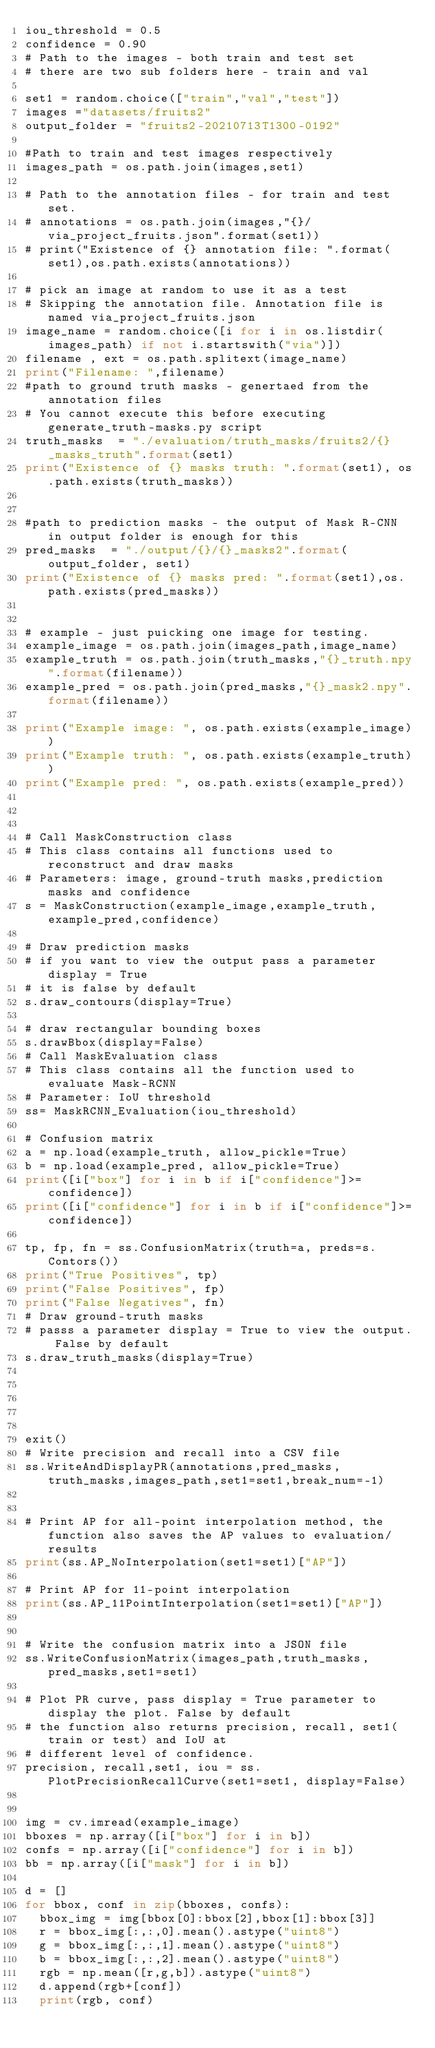<code> <loc_0><loc_0><loc_500><loc_500><_Python_>iou_threshold = 0.5
confidence = 0.90
# Path to the images - both train and test set
# there are two sub folders here - train and val

set1 = random.choice(["train","val","test"])
images ="datasets/fruits2"
output_folder = "fruits2-20210713T1300-0192"

#Path to train and test images respectively
images_path = os.path.join(images,set1)

# Path to the annotation files - for train and test set.
# annotations = os.path.join(images,"{}/via_project_fruits.json".format(set1))
# print("Existence of {} annotation file: ".format(set1),os.path.exists(annotations))

# pick an image at random to use it as a test 
# Skipping the annotation file. Annotation file is named via_project_fruits.json
image_name = random.choice([i for i in os.listdir(images_path) if not i.startswith("via")])
filename , ext = os.path.splitext(image_name)
print("Filename: ",filename)
#path to ground truth masks - genertaed from the annotation files
# You cannot execute this before executing generate_truth-masks.py script
truth_masks  = "./evaluation/truth_masks/fruits2/{}_masks_truth".format(set1)
print("Existence of {} masks truth: ".format(set1), os.path.exists(truth_masks))


#path to prediction masks - the output of Mask R-CNN in output folder is enough for this
pred_masks  = "./output/{}/{}_masks2".format(output_folder, set1)
print("Existence of {} masks pred: ".format(set1),os.path.exists(pred_masks))


# example - just puicking one image for testing.
example_image = os.path.join(images_path,image_name)
example_truth = os.path.join(truth_masks,"{}_truth.npy".format(filename))
example_pred = os.path.join(pred_masks,"{}_mask2.npy".format(filename))

print("Example image: ", os.path.exists(example_image))
print("Example truth: ", os.path.exists(example_truth))
print("Example pred: ", os.path.exists(example_pred))



# Call MaskConstruction class 
# This class contains all functions used to reconstruct and draw masks
# Parameters: image, ground-truth masks,prediction masks and confidence
s = MaskConstruction(example_image,example_truth,example_pred,confidence)

# Draw prediction masks
# if you want to view the output pass a parameter display = True
# it is false by default
s.draw_contours(display=True)

# draw rectangular bounding boxes 
s.drawBbox(display=False)
# Call MaskEvaluation class
# This class contains all the function used to evaluate Mask-RCNN
# Parameter: IoU threshold
ss= MaskRCNN_Evaluation(iou_threshold)

# Confusion matrix
a = np.load(example_truth, allow_pickle=True)
b = np.load(example_pred, allow_pickle=True)
print([i["box"] for i in b if i["confidence"]>=confidence])
print([i["confidence"] for i in b if i["confidence"]>=confidence])

tp, fp, fn = ss.ConfusionMatrix(truth=a, preds=s.Contors())
print("True Positives", tp)
print("False Positives", fp)
print("False Negatives", fn)
# Draw ground-truth masks
# passs a parameter display = True to view the output. False by default
s.draw_truth_masks(display=True)





exit()
# Write precision and recall into a CSV file
ss.WriteAndDisplayPR(annotations,pred_masks,truth_masks,images_path,set1=set1,break_num=-1)


# Print AP for all-point interpolation method, the function also saves the AP values to evaluation/results
print(ss.AP_NoInterpolation(set1=set1)["AP"])

# Print AP for 11-point interpolation
print(ss.AP_11PointInterpolation(set1=set1)["AP"])


# Write the confusion matrix into a JSON file
ss.WriteConfusionMatrix(images_path,truth_masks,pred_masks,set1=set1)

# Plot PR curve, pass display = True parameter to display the plot. False by default
# the function also returns precision, recall, set1(train or test) and IoU at 
# different level of confidence.
precision, recall,set1, iou = ss.PlotPrecisionRecallCurve(set1=set1, display=False)


img = cv.imread(example_image)
bboxes = np.array([i["box"] for i in b])
confs = np.array([i["confidence"] for i in b])
bb = np.array([i["mask"] for i in b])

d = []
for bbox, conf in zip(bboxes, confs):
	bbox_img = img[bbox[0]:bbox[2],bbox[1]:bbox[3]]
	r = bbox_img[:,:,0].mean().astype("uint8")
	g = bbox_img[:,:,1].mean().astype("uint8")
	b = bbox_img[:,:,2].mean().astype("uint8")
	rgb = np.mean([r,g,b]).astype("uint8")
	d.append(rgb+[conf])
	print(rgb, conf)</code> 